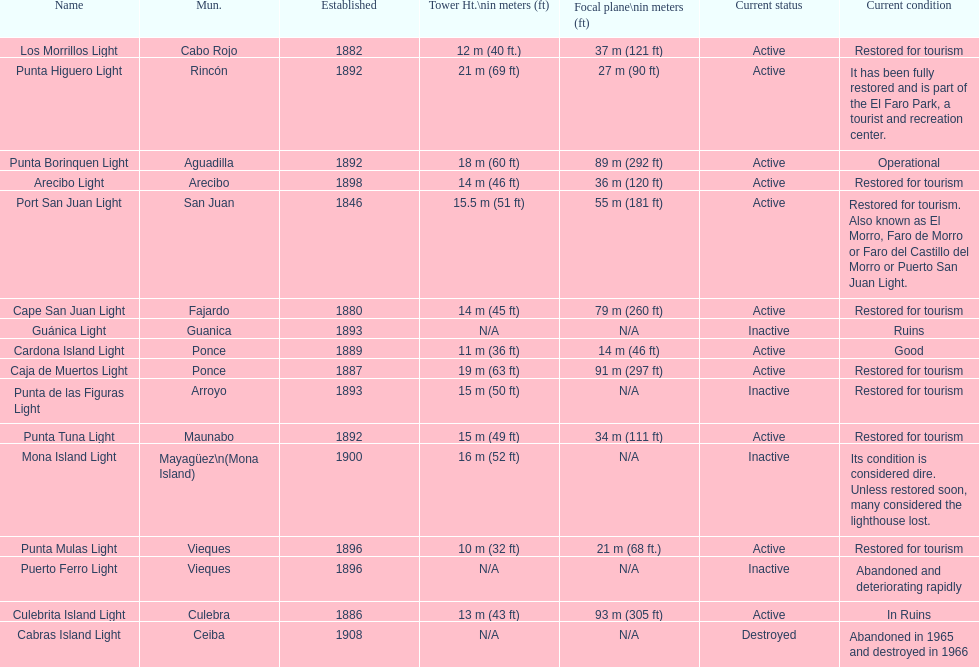How many towers are at least 18 meters tall? 3. Could you parse the entire table? {'header': ['Name', 'Mun.', 'Established', 'Tower Ht.\\nin meters (ft)', 'Focal plane\\nin meters (ft)', 'Current status', 'Current condition'], 'rows': [['Los Morrillos Light', 'Cabo Rojo', '1882', '12\xa0m (40\xa0ft.)', '37\xa0m (121\xa0ft)', 'Active', 'Restored for tourism'], ['Punta Higuero Light', 'Rincón', '1892', '21\xa0m (69\xa0ft)', '27\xa0m (90\xa0ft)', 'Active', 'It has been fully restored and is part of the El Faro Park, a tourist and recreation center.'], ['Punta Borinquen Light', 'Aguadilla', '1892', '18\xa0m (60\xa0ft)', '89\xa0m (292\xa0ft)', 'Active', 'Operational'], ['Arecibo Light', 'Arecibo', '1898', '14\xa0m (46\xa0ft)', '36\xa0m (120\xa0ft)', 'Active', 'Restored for tourism'], ['Port San Juan Light', 'San Juan', '1846', '15.5\xa0m (51\xa0ft)', '55\xa0m (181\xa0ft)', 'Active', 'Restored for tourism. Also known as El Morro, Faro de Morro or Faro del Castillo del Morro or Puerto San Juan Light.'], ['Cape San Juan Light', 'Fajardo', '1880', '14\xa0m (45\xa0ft)', '79\xa0m (260\xa0ft)', 'Active', 'Restored for tourism'], ['Guánica Light', 'Guanica', '1893', 'N/A', 'N/A', 'Inactive', 'Ruins'], ['Cardona Island Light', 'Ponce', '1889', '11\xa0m (36\xa0ft)', '14\xa0m (46\xa0ft)', 'Active', 'Good'], ['Caja de Muertos Light', 'Ponce', '1887', '19\xa0m (63\xa0ft)', '91\xa0m (297\xa0ft)', 'Active', 'Restored for tourism'], ['Punta de las Figuras Light', 'Arroyo', '1893', '15\xa0m (50\xa0ft)', 'N/A', 'Inactive', 'Restored for tourism'], ['Punta Tuna Light', 'Maunabo', '1892', '15\xa0m (49\xa0ft)', '34\xa0m (111\xa0ft)', 'Active', 'Restored for tourism'], ['Mona Island Light', 'Mayagüez\\n(Mona Island)', '1900', '16\xa0m (52\xa0ft)', 'N/A', 'Inactive', 'Its condition is considered dire. Unless restored soon, many considered the lighthouse lost.'], ['Punta Mulas Light', 'Vieques', '1896', '10\xa0m (32\xa0ft)', '21\xa0m (68\xa0ft.)', 'Active', 'Restored for tourism'], ['Puerto Ferro Light', 'Vieques', '1896', 'N/A', 'N/A', 'Inactive', 'Abandoned and deteriorating rapidly'], ['Culebrita Island Light', 'Culebra', '1886', '13\xa0m (43\xa0ft)', '93\xa0m (305\xa0ft)', 'Active', 'In Ruins'], ['Cabras Island Light', 'Ceiba', '1908', 'N/A', 'N/A', 'Destroyed', 'Abandoned in 1965 and destroyed in 1966']]} 